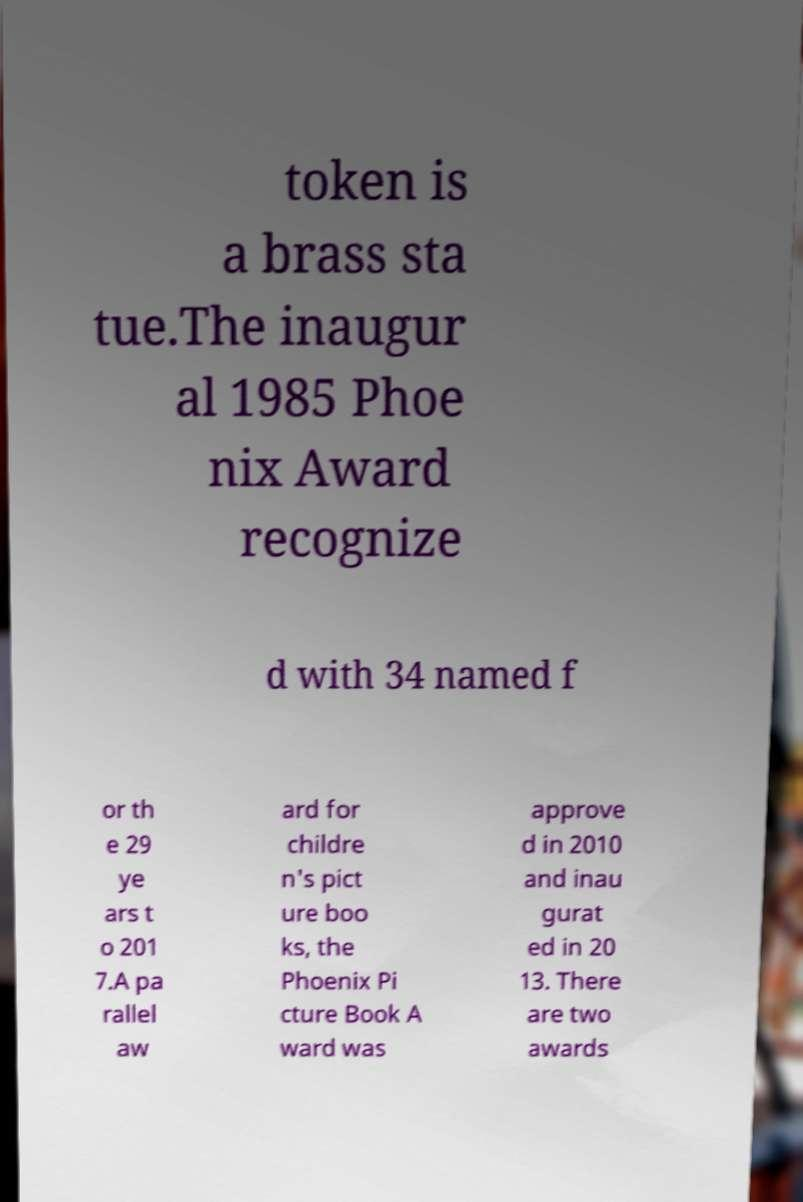Can you accurately transcribe the text from the provided image for me? token is a brass sta tue.The inaugur al 1985 Phoe nix Award recognize d with 34 named f or th e 29 ye ars t o 201 7.A pa rallel aw ard for childre n's pict ure boo ks, the Phoenix Pi cture Book A ward was approve d in 2010 and inau gurat ed in 20 13. There are two awards 